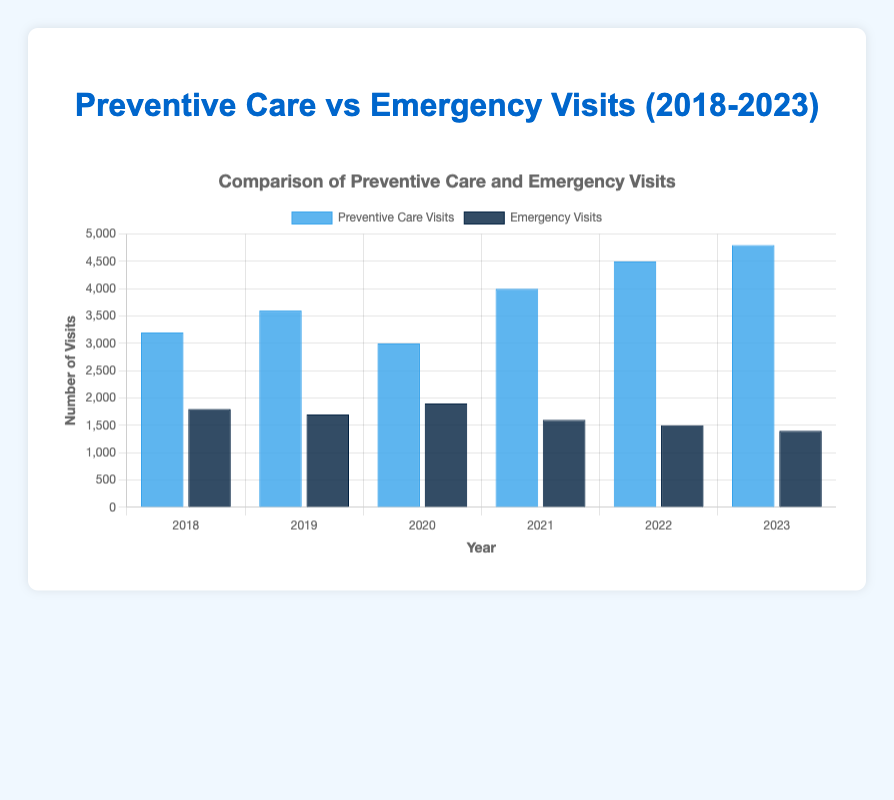What's the total number of Preventive Care Visits from 2018 to 2023? To find the total, sum up the individual yearly counts of Preventive Care Visits: 3200 + 3600 + 3000 + 4000 + 4500 + 4800 = 23100
Answer: 23100 What's the difference in the number of Preventive Care Visits between 2023 and 2018? Subtract the number of Preventive Care Visits in 2018 from the number in 2023: 4800 - 3200 = 1600
Answer: 1600 In which year was the highest number of Emergency Visits recorded? Look at the bar heights for Emergency Visits across all years and find the tallest bar. The year with the highest number of Emergency Visits is 2020 with 1900 visits.
Answer: 2020 What is the trend of Preventive Care Visits from 2018 to 2023? Analyze the height of the bars representing Preventive Care Visits over the years. The trend is increasing overall, though there is a slight dip in 2020.
Answer: Increasing Compare the number of Preventive Care Visits and Emergency Visits for the year 2021. Which category has more visits and by how much? Compare the bar heights in 2021. Preventive Care Visits in 2021 are 4000, while Emergency Visits are 1600. The difference is 4000 - 1600 = 2400, with Preventive Care Visits being higher.
Answer: Preventive Care Visits by 2400 What is the average number of Preventive Care Visits between 2018 and 2023? Calculate the sum of Preventive Care Visits from 2018 to 2023 and divide by the number of years. (3200 + 3600 + 3000 + 4000 + 4500 + 4800) / 6 = 3850
Answer: 3850 How much did Emergency Visits decrease from 2018 to 2023? Subtract the number of Emergency Visits in 2023 from the number in 2018: 1800 - 1400 = 400
Answer: 400 Which year has a greater number of Preventive Care Visits than Emergency Visits by exactly 2900 visits? By comparing differences each year: 
2018: 3200 - 1800 = 1400,
2019: 3600 - 1700 = 1900,
2020: 3000 - 1900 = 1100,
2021: 4000 - 1600 = 2400,
2022: 4500 - 1500 = 3000,
2023: 4800 - 1400 = 3400.
So, no year has a difference of exactly 2900.
Answer: None By how much did the number of Preventive Care Visits increase from 2020 to 2021? Subtract the number of visits in 2020 from the number in 2021: 4000 - 3000 = 1000
Answer: 1000 